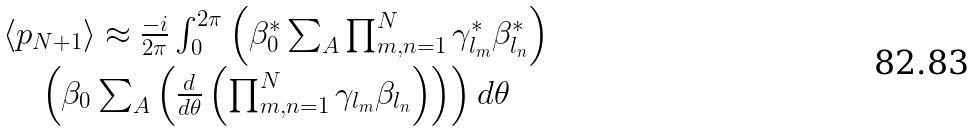<formula> <loc_0><loc_0><loc_500><loc_500>\begin{array} { c c } \langle p _ { N + 1 } \rangle \approx \frac { - i } { 2 \pi } \int _ { 0 } ^ { 2 \pi } \left ( \beta ^ { * } _ { 0 } \sum _ { A } \prod _ { m , n = 1 } ^ { N } \gamma ^ { * } _ { l _ { m } } \beta ^ { * } _ { l _ { n } } \right ) \\ \left ( \beta _ { 0 } \sum _ { A } \left ( \frac { d } { d \theta } \left ( \prod _ { m , n = 1 } ^ { N } \gamma _ { l _ { m } } \beta _ { l _ { n } } \right ) \right ) \right ) d \theta \end{array}</formula> 